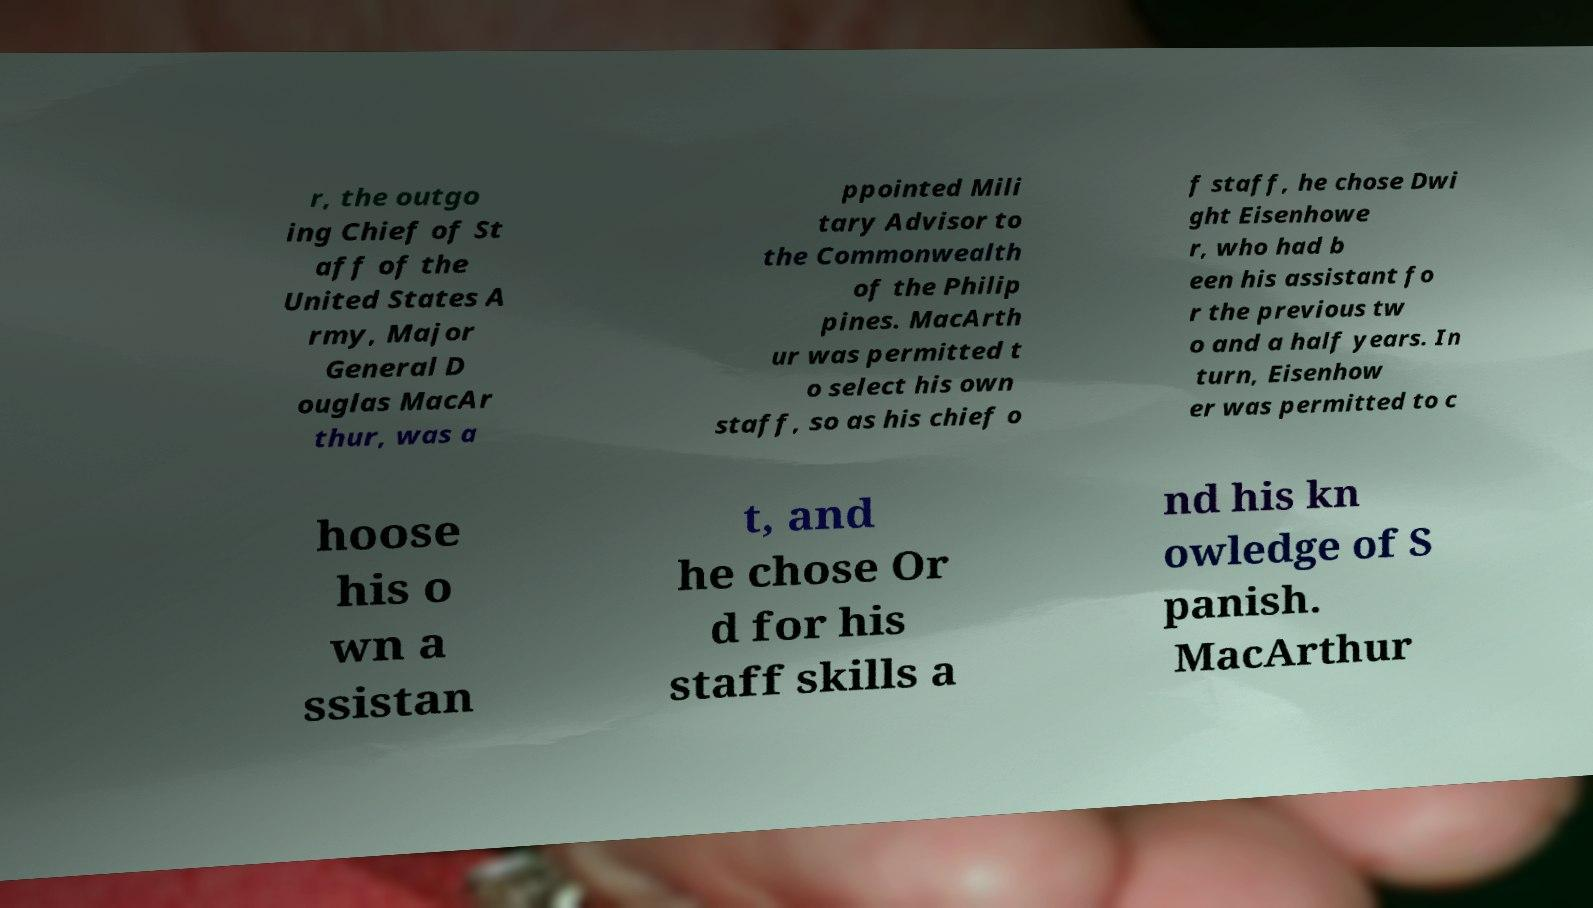Can you accurately transcribe the text from the provided image for me? r, the outgo ing Chief of St aff of the United States A rmy, Major General D ouglas MacAr thur, was a ppointed Mili tary Advisor to the Commonwealth of the Philip pines. MacArth ur was permitted t o select his own staff, so as his chief o f staff, he chose Dwi ght Eisenhowe r, who had b een his assistant fo r the previous tw o and a half years. In turn, Eisenhow er was permitted to c hoose his o wn a ssistan t, and he chose Or d for his staff skills a nd his kn owledge of S panish. MacArthur 